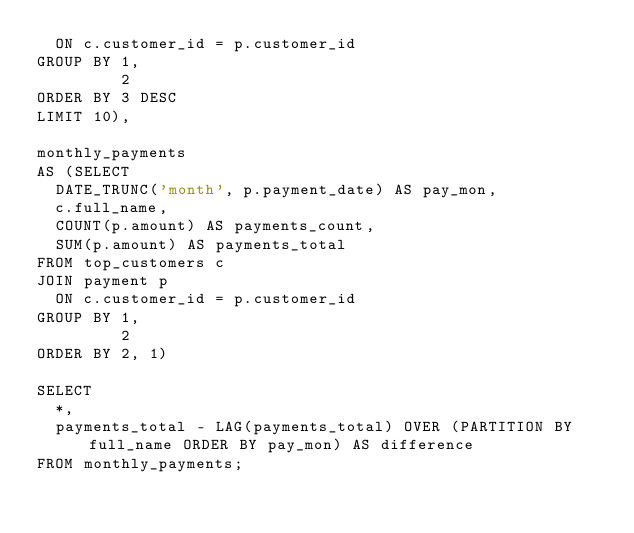Convert code to text. <code><loc_0><loc_0><loc_500><loc_500><_SQL_>  ON c.customer_id = p.customer_id
GROUP BY 1,
         2
ORDER BY 3 DESC
LIMIT 10),

monthly_payments
AS (SELECT
  DATE_TRUNC('month', p.payment_date) AS pay_mon,
  c.full_name,
  COUNT(p.amount) AS payments_count,
  SUM(p.amount) AS payments_total
FROM top_customers c
JOIN payment p
  ON c.customer_id = p.customer_id
GROUP BY 1,
         2
ORDER BY 2, 1)

SELECT
  *,
  payments_total - LAG(payments_total) OVER (PARTITION BY full_name ORDER BY pay_mon) AS difference
FROM monthly_payments;</code> 